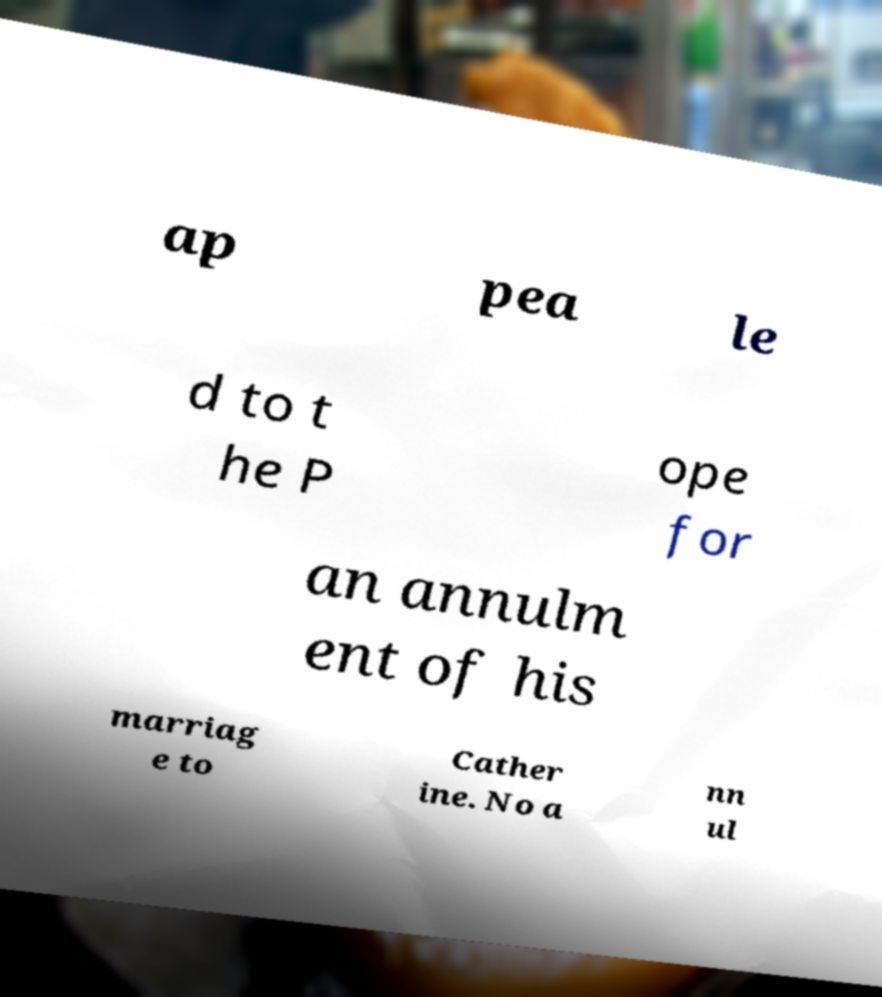What messages or text are displayed in this image? I need them in a readable, typed format. ap pea le d to t he P ope for an annulm ent of his marriag e to Cather ine. No a nn ul 